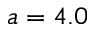<formula> <loc_0><loc_0><loc_500><loc_500>a = 4 . 0</formula> 